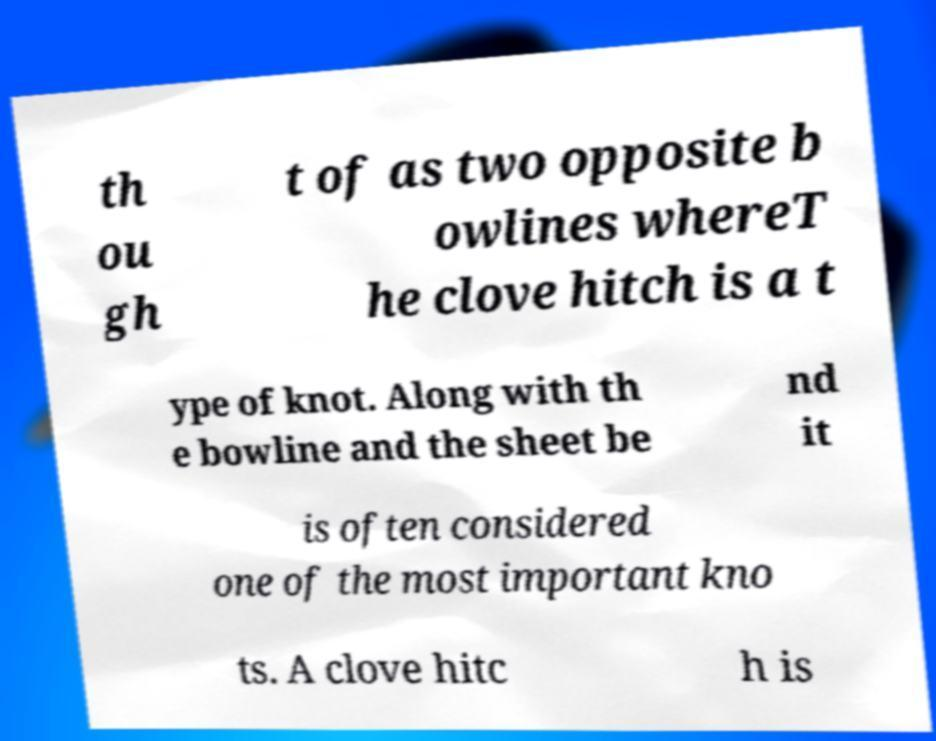I need the written content from this picture converted into text. Can you do that? th ou gh t of as two opposite b owlines whereT he clove hitch is a t ype of knot. Along with th e bowline and the sheet be nd it is often considered one of the most important kno ts. A clove hitc h is 